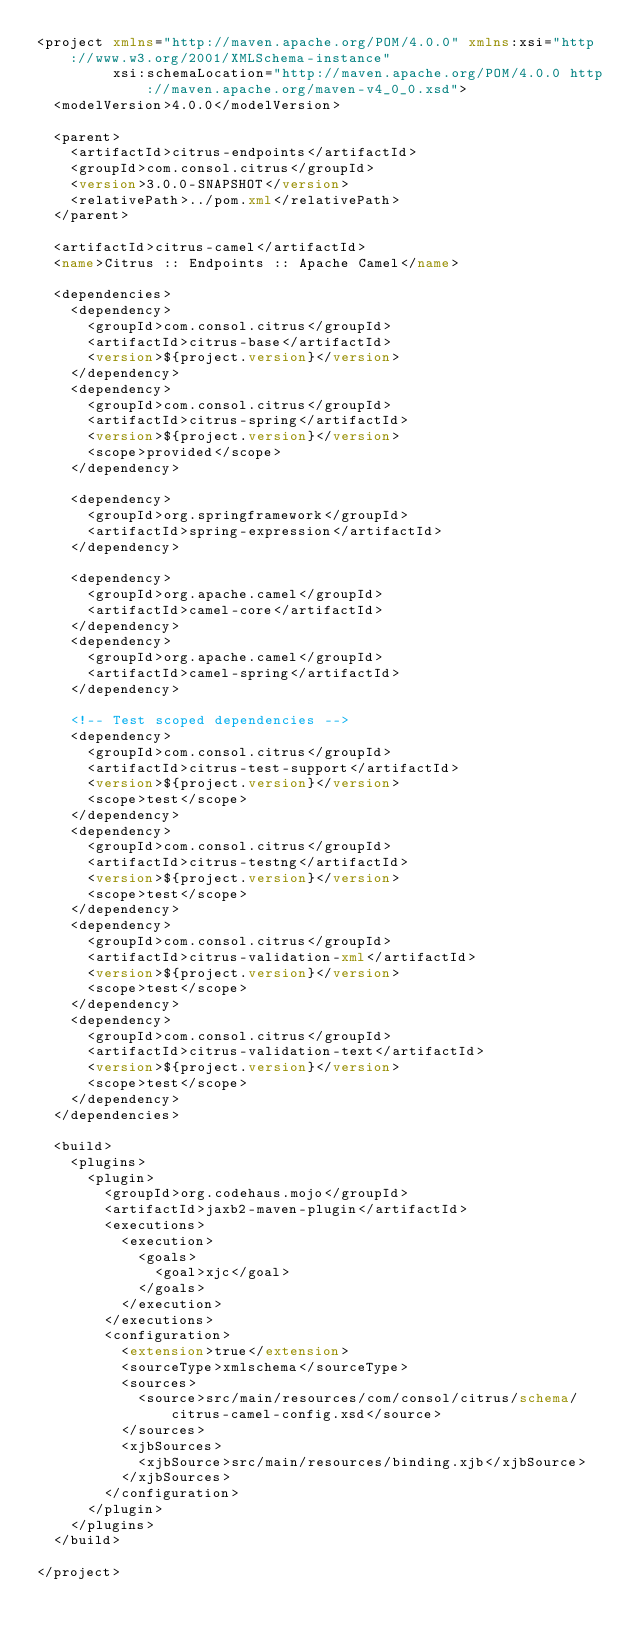<code> <loc_0><loc_0><loc_500><loc_500><_XML_><project xmlns="http://maven.apache.org/POM/4.0.0" xmlns:xsi="http://www.w3.org/2001/XMLSchema-instance"
         xsi:schemaLocation="http://maven.apache.org/POM/4.0.0 http://maven.apache.org/maven-v4_0_0.xsd">
  <modelVersion>4.0.0</modelVersion>

  <parent>
    <artifactId>citrus-endpoints</artifactId>
    <groupId>com.consol.citrus</groupId>
    <version>3.0.0-SNAPSHOT</version>
    <relativePath>../pom.xml</relativePath>
  </parent>

  <artifactId>citrus-camel</artifactId>
  <name>Citrus :: Endpoints :: Apache Camel</name>

  <dependencies>
    <dependency>
      <groupId>com.consol.citrus</groupId>
      <artifactId>citrus-base</artifactId>
      <version>${project.version}</version>
    </dependency>
    <dependency>
      <groupId>com.consol.citrus</groupId>
      <artifactId>citrus-spring</artifactId>
      <version>${project.version}</version>
      <scope>provided</scope>
    </dependency>

    <dependency>
      <groupId>org.springframework</groupId>
      <artifactId>spring-expression</artifactId>
    </dependency>

    <dependency>
      <groupId>org.apache.camel</groupId>
      <artifactId>camel-core</artifactId>
    </dependency>
    <dependency>
      <groupId>org.apache.camel</groupId>
      <artifactId>camel-spring</artifactId>
    </dependency>

    <!-- Test scoped dependencies -->
    <dependency>
      <groupId>com.consol.citrus</groupId>
      <artifactId>citrus-test-support</artifactId>
      <version>${project.version}</version>
      <scope>test</scope>
    </dependency>
    <dependency>
      <groupId>com.consol.citrus</groupId>
      <artifactId>citrus-testng</artifactId>
      <version>${project.version}</version>
      <scope>test</scope>
    </dependency>
    <dependency>
      <groupId>com.consol.citrus</groupId>
      <artifactId>citrus-validation-xml</artifactId>
      <version>${project.version}</version>
      <scope>test</scope>
    </dependency>
    <dependency>
      <groupId>com.consol.citrus</groupId>
      <artifactId>citrus-validation-text</artifactId>
      <version>${project.version}</version>
      <scope>test</scope>
    </dependency>
  </dependencies>

  <build>
    <plugins>
      <plugin>
        <groupId>org.codehaus.mojo</groupId>
        <artifactId>jaxb2-maven-plugin</artifactId>
        <executions>
          <execution>
            <goals>
              <goal>xjc</goal>
            </goals>
          </execution>
        </executions>
        <configuration>
          <extension>true</extension>
          <sourceType>xmlschema</sourceType>
          <sources>
            <source>src/main/resources/com/consol/citrus/schema/citrus-camel-config.xsd</source>
          </sources>
          <xjbSources>
            <xjbSource>src/main/resources/binding.xjb</xjbSource>
          </xjbSources>
        </configuration>
      </plugin>
    </plugins>
  </build>

</project>
</code> 